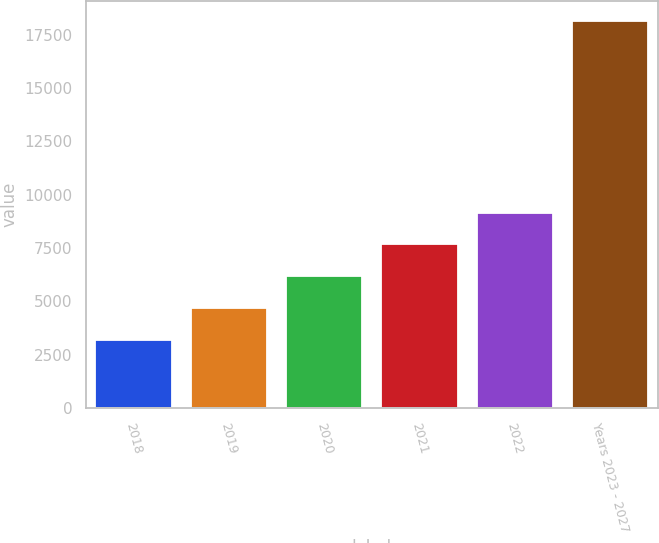Convert chart. <chart><loc_0><loc_0><loc_500><loc_500><bar_chart><fcel>2018<fcel>2019<fcel>2020<fcel>2021<fcel>2022<fcel>Years 2023 - 2027<nl><fcel>3173<fcel>4670.4<fcel>6167.8<fcel>7665.2<fcel>9162.6<fcel>18147<nl></chart> 